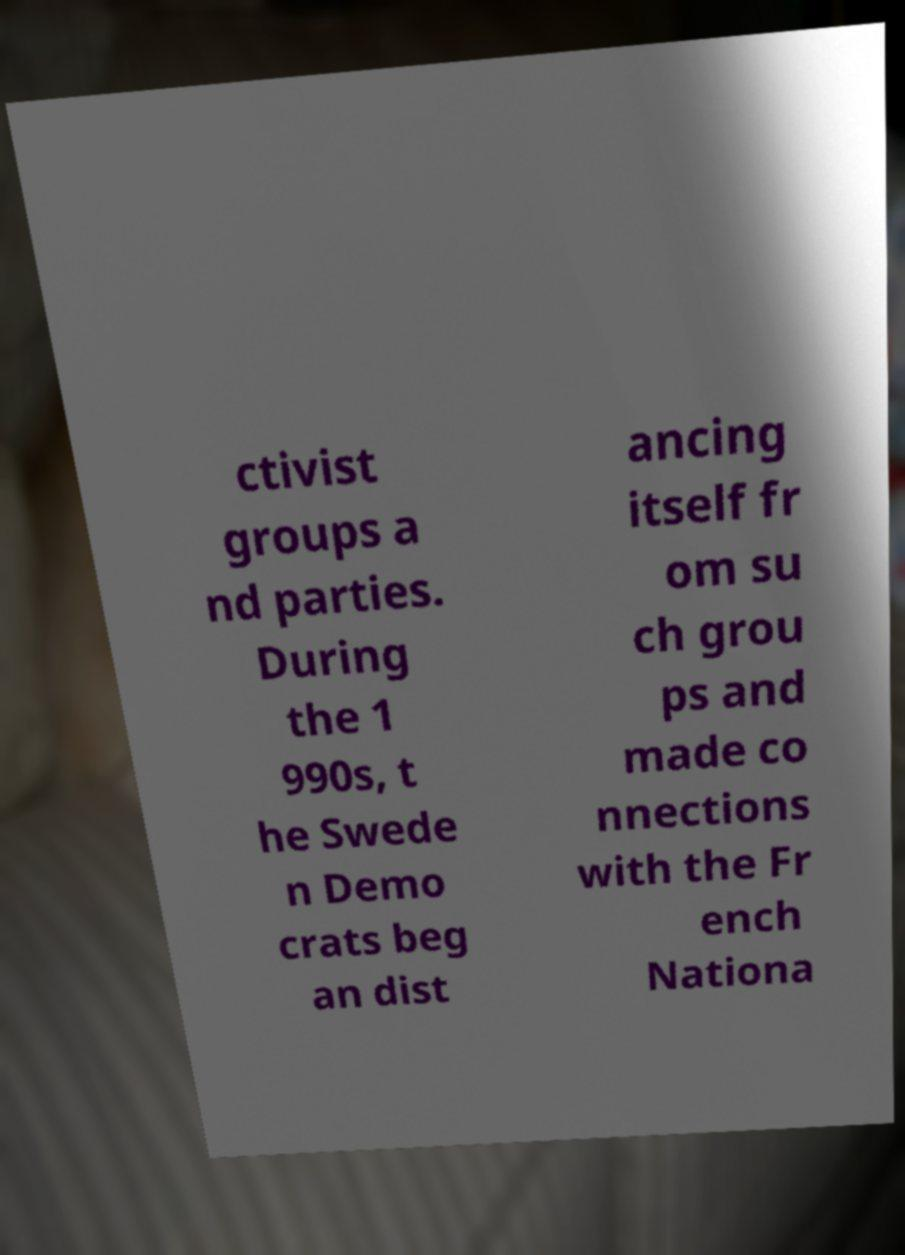Can you accurately transcribe the text from the provided image for me? ctivist groups a nd parties. During the 1 990s, t he Swede n Demo crats beg an dist ancing itself fr om su ch grou ps and made co nnections with the Fr ench Nationa 